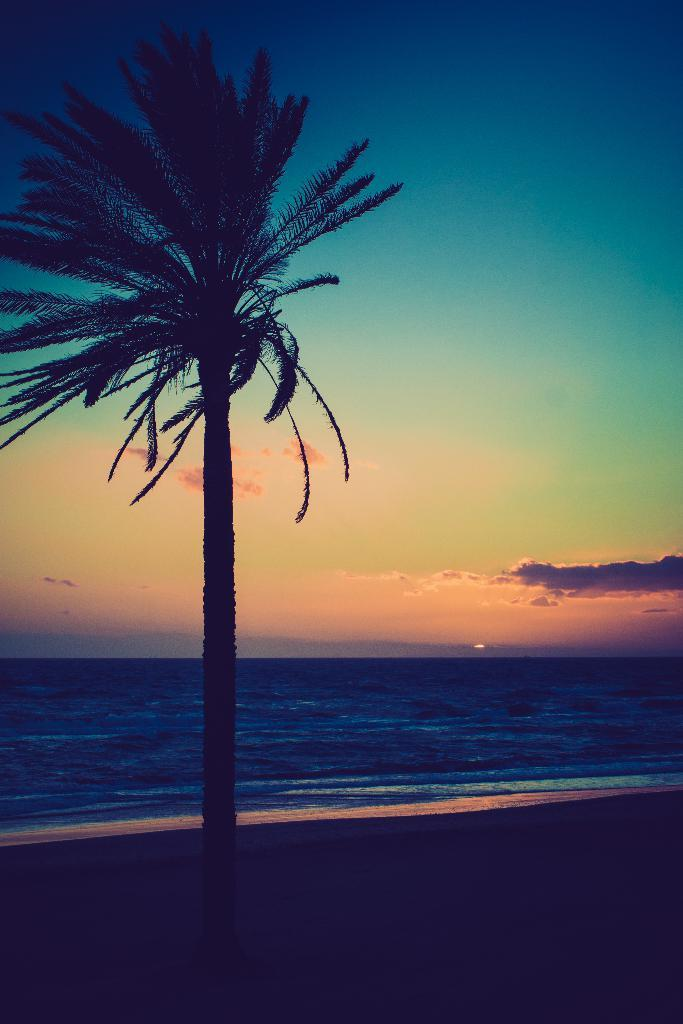What type of vegetation is on the left side of the image? There is a tree on the left side of the image. What natural feature can be seen in the background of the image? There is a sea in the background of the image. What is visible at the top of the image? The sky is visible at the top of the image. Where is the faucet located in the image? There is no faucet present in the image. What type of steam can be seen coming from the tree in the image? There is no steam coming from the tree in the image. 